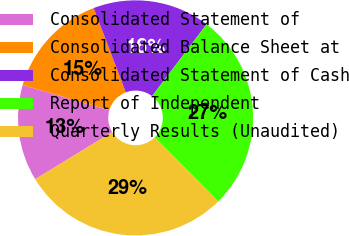Convert chart to OTSL. <chart><loc_0><loc_0><loc_500><loc_500><pie_chart><fcel>Consolidated Statement of<fcel>Consolidated Balance Sheet at<fcel>Consolidated Statement of Cash<fcel>Report of Independent<fcel>Quarterly Results (Unaudited)<nl><fcel>13.25%<fcel>14.69%<fcel>16.13%<fcel>27.25%<fcel>28.68%<nl></chart> 